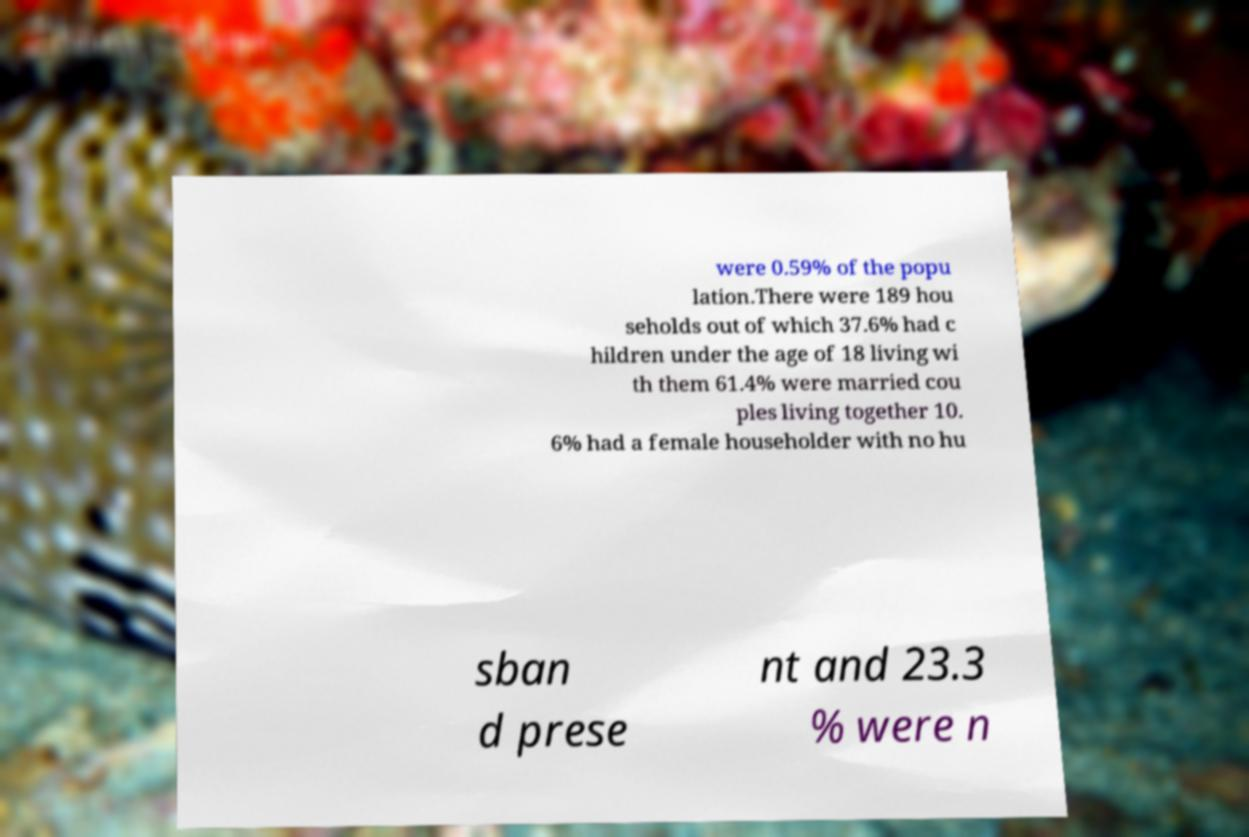I need the written content from this picture converted into text. Can you do that? were 0.59% of the popu lation.There were 189 hou seholds out of which 37.6% had c hildren under the age of 18 living wi th them 61.4% were married cou ples living together 10. 6% had a female householder with no hu sban d prese nt and 23.3 % were n 